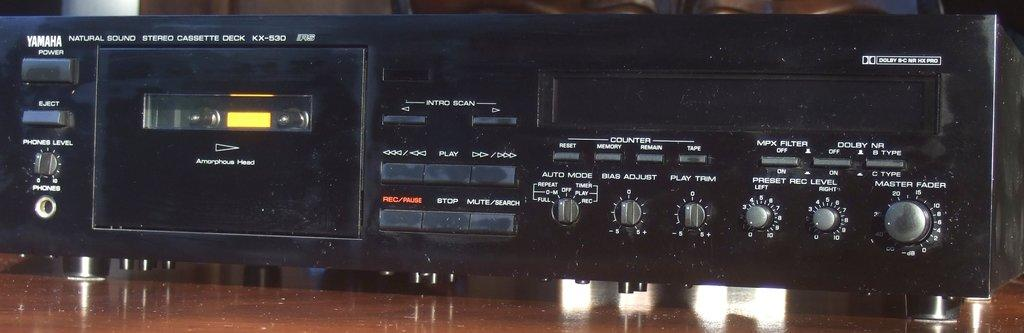<image>
Describe the image concisely. yamaha power player in black placed on the desk 